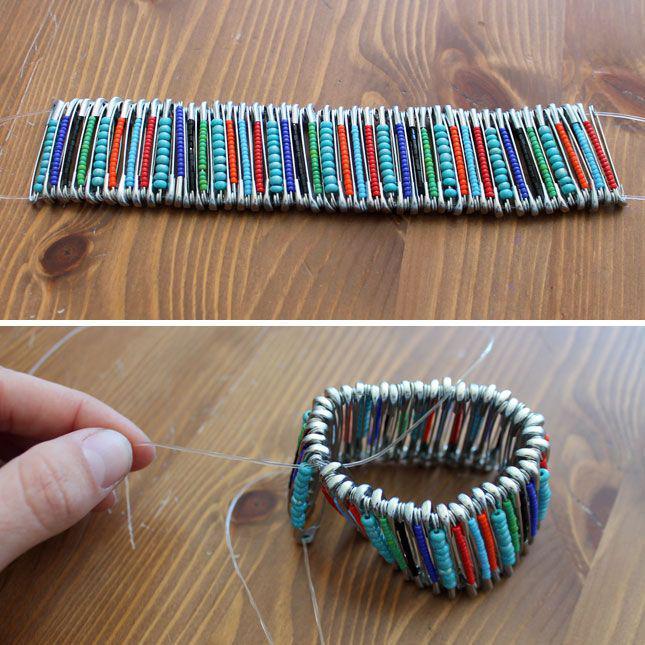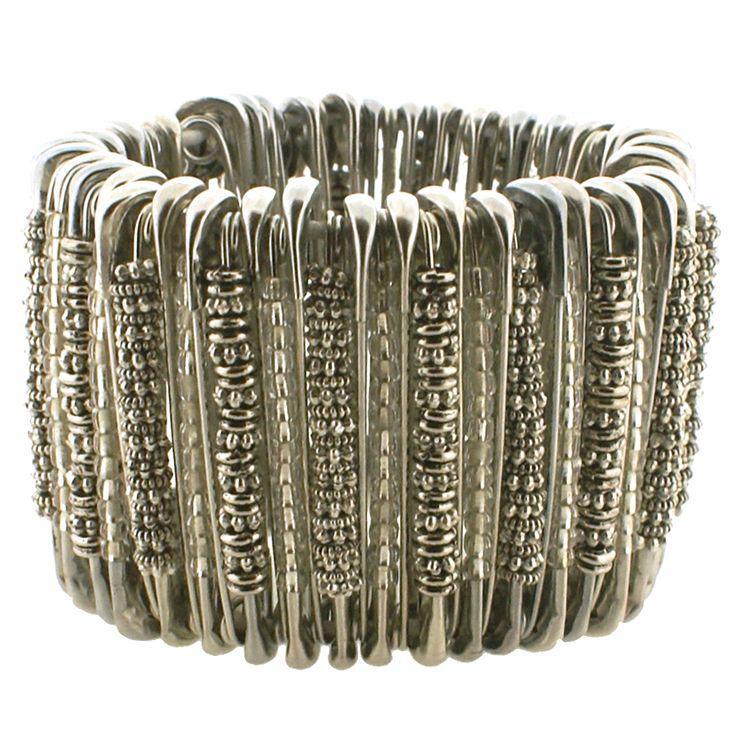The first image is the image on the left, the second image is the image on the right. Given the left and right images, does the statement "A bracelet is being modeled in the image on the left." hold true? Answer yes or no. No. The first image is the image on the left, the second image is the image on the right. For the images displayed, is the sentence "The left image contains a persons wrist modeling a bracelet with many beads." factually correct? Answer yes or no. No. 